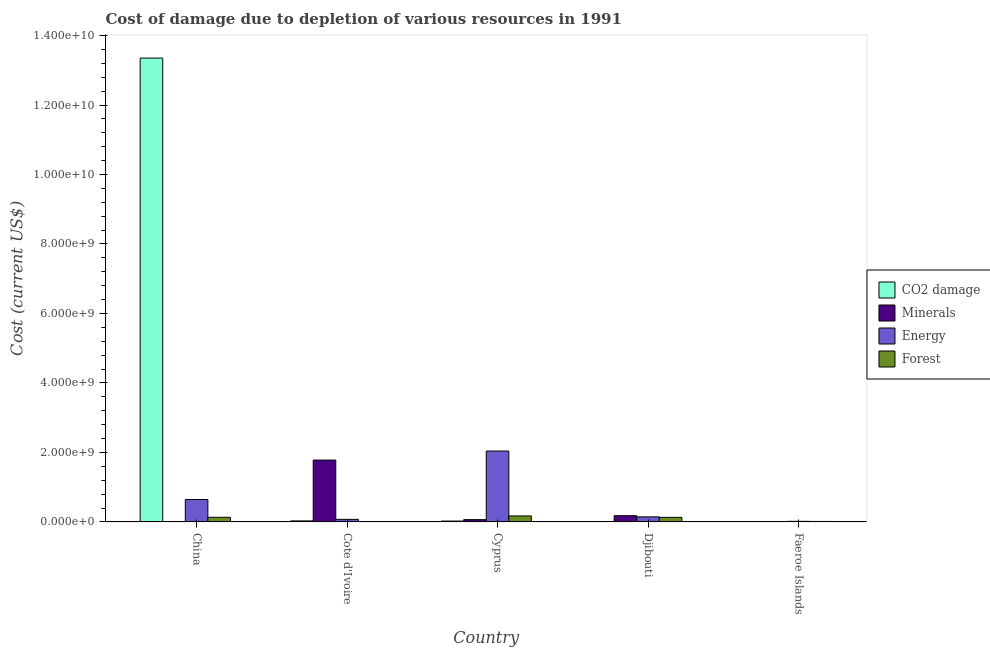How many groups of bars are there?
Keep it short and to the point. 5. How many bars are there on the 3rd tick from the left?
Your answer should be very brief. 4. How many bars are there on the 2nd tick from the right?
Keep it short and to the point. 4. What is the label of the 4th group of bars from the left?
Make the answer very short. Djibouti. What is the cost of damage due to depletion of coal in China?
Your response must be concise. 1.34e+1. Across all countries, what is the maximum cost of damage due to depletion of coal?
Provide a short and direct response. 1.34e+1. Across all countries, what is the minimum cost of damage due to depletion of energy?
Offer a very short reply. 1.68e+07. What is the total cost of damage due to depletion of forests in the graph?
Give a very brief answer. 4.50e+08. What is the difference between the cost of damage due to depletion of energy in China and that in Cote d'Ivoire?
Your answer should be very brief. 5.71e+08. What is the difference between the cost of damage due to depletion of coal in China and the cost of damage due to depletion of energy in Cote d'Ivoire?
Provide a succinct answer. 1.33e+1. What is the average cost of damage due to depletion of minerals per country?
Provide a succinct answer. 4.05e+08. What is the difference between the cost of damage due to depletion of coal and cost of damage due to depletion of energy in Cyprus?
Your answer should be compact. -2.02e+09. In how many countries, is the cost of damage due to depletion of forests greater than 9600000000 US$?
Provide a short and direct response. 0. What is the ratio of the cost of damage due to depletion of forests in Cyprus to that in Djibouti?
Offer a very short reply. 1.31. Is the difference between the cost of damage due to depletion of forests in Cote d'Ivoire and Djibouti greater than the difference between the cost of damage due to depletion of minerals in Cote d'Ivoire and Djibouti?
Make the answer very short. No. What is the difference between the highest and the second highest cost of damage due to depletion of minerals?
Your response must be concise. 1.60e+09. What is the difference between the highest and the lowest cost of damage due to depletion of coal?
Ensure brevity in your answer.  1.33e+1. Is it the case that in every country, the sum of the cost of damage due to depletion of minerals and cost of damage due to depletion of coal is greater than the sum of cost of damage due to depletion of energy and cost of damage due to depletion of forests?
Ensure brevity in your answer.  No. What does the 3rd bar from the left in China represents?
Give a very brief answer. Energy. What does the 3rd bar from the right in Cote d'Ivoire represents?
Your response must be concise. Minerals. Is it the case that in every country, the sum of the cost of damage due to depletion of coal and cost of damage due to depletion of minerals is greater than the cost of damage due to depletion of energy?
Provide a succinct answer. No. How many bars are there?
Offer a very short reply. 20. How many countries are there in the graph?
Provide a short and direct response. 5. Where does the legend appear in the graph?
Keep it short and to the point. Center right. How many legend labels are there?
Your answer should be very brief. 4. What is the title of the graph?
Give a very brief answer. Cost of damage due to depletion of various resources in 1991 . Does "UNRWA" appear as one of the legend labels in the graph?
Make the answer very short. No. What is the label or title of the X-axis?
Give a very brief answer. Country. What is the label or title of the Y-axis?
Offer a very short reply. Cost (current US$). What is the Cost (current US$) of CO2 damage in China?
Keep it short and to the point. 1.34e+1. What is the Cost (current US$) of Minerals in China?
Offer a terse response. 5762.35. What is the Cost (current US$) in Energy in China?
Provide a short and direct response. 6.45e+08. What is the Cost (current US$) of Forest in China?
Give a very brief answer. 1.33e+08. What is the Cost (current US$) in CO2 damage in Cote d'Ivoire?
Your response must be concise. 2.91e+07. What is the Cost (current US$) in Minerals in Cote d'Ivoire?
Keep it short and to the point. 1.78e+09. What is the Cost (current US$) in Energy in Cote d'Ivoire?
Make the answer very short. 7.38e+07. What is the Cost (current US$) of Forest in Cote d'Ivoire?
Offer a terse response. 2.44e+05. What is the Cost (current US$) of CO2 damage in Cyprus?
Make the answer very short. 2.45e+07. What is the Cost (current US$) of Minerals in Cyprus?
Offer a very short reply. 6.52e+07. What is the Cost (current US$) of Energy in Cyprus?
Keep it short and to the point. 2.04e+09. What is the Cost (current US$) of Forest in Cyprus?
Your answer should be compact. 1.72e+08. What is the Cost (current US$) in CO2 damage in Djibouti?
Provide a short and direct response. 1.97e+06. What is the Cost (current US$) of Minerals in Djibouti?
Give a very brief answer. 1.79e+08. What is the Cost (current US$) of Energy in Djibouti?
Provide a short and direct response. 1.45e+08. What is the Cost (current US$) in Forest in Djibouti?
Your response must be concise. 1.31e+08. What is the Cost (current US$) of CO2 damage in Faeroe Islands?
Your answer should be compact. 3.07e+06. What is the Cost (current US$) in Minerals in Faeroe Islands?
Offer a terse response. 1.46e+06. What is the Cost (current US$) of Energy in Faeroe Islands?
Keep it short and to the point. 1.68e+07. What is the Cost (current US$) of Forest in Faeroe Islands?
Offer a very short reply. 1.35e+07. Across all countries, what is the maximum Cost (current US$) in CO2 damage?
Make the answer very short. 1.34e+1. Across all countries, what is the maximum Cost (current US$) in Minerals?
Keep it short and to the point. 1.78e+09. Across all countries, what is the maximum Cost (current US$) in Energy?
Your answer should be compact. 2.04e+09. Across all countries, what is the maximum Cost (current US$) of Forest?
Ensure brevity in your answer.  1.72e+08. Across all countries, what is the minimum Cost (current US$) in CO2 damage?
Offer a very short reply. 1.97e+06. Across all countries, what is the minimum Cost (current US$) of Minerals?
Make the answer very short. 5762.35. Across all countries, what is the minimum Cost (current US$) of Energy?
Offer a terse response. 1.68e+07. Across all countries, what is the minimum Cost (current US$) in Forest?
Your answer should be compact. 2.44e+05. What is the total Cost (current US$) of CO2 damage in the graph?
Provide a succinct answer. 1.34e+1. What is the total Cost (current US$) in Minerals in the graph?
Offer a very short reply. 2.03e+09. What is the total Cost (current US$) of Energy in the graph?
Keep it short and to the point. 2.92e+09. What is the total Cost (current US$) in Forest in the graph?
Provide a succinct answer. 4.50e+08. What is the difference between the Cost (current US$) of CO2 damage in China and that in Cote d'Ivoire?
Give a very brief answer. 1.33e+1. What is the difference between the Cost (current US$) in Minerals in China and that in Cote d'Ivoire?
Make the answer very short. -1.78e+09. What is the difference between the Cost (current US$) of Energy in China and that in Cote d'Ivoire?
Ensure brevity in your answer.  5.71e+08. What is the difference between the Cost (current US$) in Forest in China and that in Cote d'Ivoire?
Keep it short and to the point. 1.33e+08. What is the difference between the Cost (current US$) of CO2 damage in China and that in Cyprus?
Provide a succinct answer. 1.33e+1. What is the difference between the Cost (current US$) in Minerals in China and that in Cyprus?
Offer a very short reply. -6.52e+07. What is the difference between the Cost (current US$) in Energy in China and that in Cyprus?
Ensure brevity in your answer.  -1.39e+09. What is the difference between the Cost (current US$) in Forest in China and that in Cyprus?
Keep it short and to the point. -3.91e+07. What is the difference between the Cost (current US$) in CO2 damage in China and that in Djibouti?
Ensure brevity in your answer.  1.33e+1. What is the difference between the Cost (current US$) of Minerals in China and that in Djibouti?
Offer a very short reply. -1.79e+08. What is the difference between the Cost (current US$) in Energy in China and that in Djibouti?
Make the answer very short. 5.00e+08. What is the difference between the Cost (current US$) of Forest in China and that in Djibouti?
Give a very brief answer. 2.08e+06. What is the difference between the Cost (current US$) of CO2 damage in China and that in Faeroe Islands?
Your response must be concise. 1.33e+1. What is the difference between the Cost (current US$) in Minerals in China and that in Faeroe Islands?
Offer a very short reply. -1.45e+06. What is the difference between the Cost (current US$) of Energy in China and that in Faeroe Islands?
Your answer should be compact. 6.28e+08. What is the difference between the Cost (current US$) in Forest in China and that in Faeroe Islands?
Your answer should be very brief. 1.20e+08. What is the difference between the Cost (current US$) of CO2 damage in Cote d'Ivoire and that in Cyprus?
Your answer should be compact. 4.62e+06. What is the difference between the Cost (current US$) in Minerals in Cote d'Ivoire and that in Cyprus?
Provide a succinct answer. 1.71e+09. What is the difference between the Cost (current US$) of Energy in Cote d'Ivoire and that in Cyprus?
Your answer should be very brief. -1.97e+09. What is the difference between the Cost (current US$) in Forest in Cote d'Ivoire and that in Cyprus?
Make the answer very short. -1.72e+08. What is the difference between the Cost (current US$) of CO2 damage in Cote d'Ivoire and that in Djibouti?
Offer a terse response. 2.71e+07. What is the difference between the Cost (current US$) in Minerals in Cote d'Ivoire and that in Djibouti?
Your response must be concise. 1.60e+09. What is the difference between the Cost (current US$) in Energy in Cote d'Ivoire and that in Djibouti?
Your answer should be very brief. -7.14e+07. What is the difference between the Cost (current US$) of Forest in Cote d'Ivoire and that in Djibouti?
Ensure brevity in your answer.  -1.31e+08. What is the difference between the Cost (current US$) in CO2 damage in Cote d'Ivoire and that in Faeroe Islands?
Offer a very short reply. 2.60e+07. What is the difference between the Cost (current US$) in Minerals in Cote d'Ivoire and that in Faeroe Islands?
Your response must be concise. 1.78e+09. What is the difference between the Cost (current US$) in Energy in Cote d'Ivoire and that in Faeroe Islands?
Offer a very short reply. 5.71e+07. What is the difference between the Cost (current US$) of Forest in Cote d'Ivoire and that in Faeroe Islands?
Offer a very short reply. -1.33e+07. What is the difference between the Cost (current US$) in CO2 damage in Cyprus and that in Djibouti?
Your answer should be compact. 2.25e+07. What is the difference between the Cost (current US$) of Minerals in Cyprus and that in Djibouti?
Keep it short and to the point. -1.13e+08. What is the difference between the Cost (current US$) of Energy in Cyprus and that in Djibouti?
Your answer should be very brief. 1.89e+09. What is the difference between the Cost (current US$) in Forest in Cyprus and that in Djibouti?
Offer a terse response. 4.12e+07. What is the difference between the Cost (current US$) in CO2 damage in Cyprus and that in Faeroe Islands?
Give a very brief answer. 2.14e+07. What is the difference between the Cost (current US$) of Minerals in Cyprus and that in Faeroe Islands?
Offer a very short reply. 6.37e+07. What is the difference between the Cost (current US$) of Energy in Cyprus and that in Faeroe Islands?
Provide a succinct answer. 2.02e+09. What is the difference between the Cost (current US$) in Forest in Cyprus and that in Faeroe Islands?
Ensure brevity in your answer.  1.59e+08. What is the difference between the Cost (current US$) of CO2 damage in Djibouti and that in Faeroe Islands?
Your answer should be compact. -1.10e+06. What is the difference between the Cost (current US$) of Minerals in Djibouti and that in Faeroe Islands?
Offer a very short reply. 1.77e+08. What is the difference between the Cost (current US$) of Energy in Djibouti and that in Faeroe Islands?
Your response must be concise. 1.29e+08. What is the difference between the Cost (current US$) of Forest in Djibouti and that in Faeroe Islands?
Your answer should be very brief. 1.18e+08. What is the difference between the Cost (current US$) of CO2 damage in China and the Cost (current US$) of Minerals in Cote d'Ivoire?
Make the answer very short. 1.16e+1. What is the difference between the Cost (current US$) in CO2 damage in China and the Cost (current US$) in Energy in Cote d'Ivoire?
Provide a short and direct response. 1.33e+1. What is the difference between the Cost (current US$) in CO2 damage in China and the Cost (current US$) in Forest in Cote d'Ivoire?
Your response must be concise. 1.34e+1. What is the difference between the Cost (current US$) in Minerals in China and the Cost (current US$) in Energy in Cote d'Ivoire?
Provide a succinct answer. -7.38e+07. What is the difference between the Cost (current US$) of Minerals in China and the Cost (current US$) of Forest in Cote d'Ivoire?
Keep it short and to the point. -2.39e+05. What is the difference between the Cost (current US$) in Energy in China and the Cost (current US$) in Forest in Cote d'Ivoire?
Offer a terse response. 6.45e+08. What is the difference between the Cost (current US$) of CO2 damage in China and the Cost (current US$) of Minerals in Cyprus?
Ensure brevity in your answer.  1.33e+1. What is the difference between the Cost (current US$) of CO2 damage in China and the Cost (current US$) of Energy in Cyprus?
Provide a succinct answer. 1.13e+1. What is the difference between the Cost (current US$) of CO2 damage in China and the Cost (current US$) of Forest in Cyprus?
Your response must be concise. 1.32e+1. What is the difference between the Cost (current US$) in Minerals in China and the Cost (current US$) in Energy in Cyprus?
Ensure brevity in your answer.  -2.04e+09. What is the difference between the Cost (current US$) in Minerals in China and the Cost (current US$) in Forest in Cyprus?
Keep it short and to the point. -1.72e+08. What is the difference between the Cost (current US$) of Energy in China and the Cost (current US$) of Forest in Cyprus?
Provide a succinct answer. 4.73e+08. What is the difference between the Cost (current US$) of CO2 damage in China and the Cost (current US$) of Minerals in Djibouti?
Your answer should be compact. 1.32e+1. What is the difference between the Cost (current US$) of CO2 damage in China and the Cost (current US$) of Energy in Djibouti?
Make the answer very short. 1.32e+1. What is the difference between the Cost (current US$) of CO2 damage in China and the Cost (current US$) of Forest in Djibouti?
Ensure brevity in your answer.  1.32e+1. What is the difference between the Cost (current US$) in Minerals in China and the Cost (current US$) in Energy in Djibouti?
Offer a terse response. -1.45e+08. What is the difference between the Cost (current US$) in Minerals in China and the Cost (current US$) in Forest in Djibouti?
Provide a short and direct response. -1.31e+08. What is the difference between the Cost (current US$) in Energy in China and the Cost (current US$) in Forest in Djibouti?
Keep it short and to the point. 5.14e+08. What is the difference between the Cost (current US$) of CO2 damage in China and the Cost (current US$) of Minerals in Faeroe Islands?
Keep it short and to the point. 1.33e+1. What is the difference between the Cost (current US$) in CO2 damage in China and the Cost (current US$) in Energy in Faeroe Islands?
Offer a very short reply. 1.33e+1. What is the difference between the Cost (current US$) in CO2 damage in China and the Cost (current US$) in Forest in Faeroe Islands?
Provide a short and direct response. 1.33e+1. What is the difference between the Cost (current US$) of Minerals in China and the Cost (current US$) of Energy in Faeroe Islands?
Your answer should be very brief. -1.68e+07. What is the difference between the Cost (current US$) in Minerals in China and the Cost (current US$) in Forest in Faeroe Islands?
Your response must be concise. -1.35e+07. What is the difference between the Cost (current US$) of Energy in China and the Cost (current US$) of Forest in Faeroe Islands?
Make the answer very short. 6.31e+08. What is the difference between the Cost (current US$) of CO2 damage in Cote d'Ivoire and the Cost (current US$) of Minerals in Cyprus?
Make the answer very short. -3.61e+07. What is the difference between the Cost (current US$) in CO2 damage in Cote d'Ivoire and the Cost (current US$) in Energy in Cyprus?
Offer a terse response. -2.01e+09. What is the difference between the Cost (current US$) of CO2 damage in Cote d'Ivoire and the Cost (current US$) of Forest in Cyprus?
Offer a terse response. -1.43e+08. What is the difference between the Cost (current US$) in Minerals in Cote d'Ivoire and the Cost (current US$) in Energy in Cyprus?
Make the answer very short. -2.60e+08. What is the difference between the Cost (current US$) in Minerals in Cote d'Ivoire and the Cost (current US$) in Forest in Cyprus?
Provide a short and direct response. 1.61e+09. What is the difference between the Cost (current US$) of Energy in Cote d'Ivoire and the Cost (current US$) of Forest in Cyprus?
Make the answer very short. -9.84e+07. What is the difference between the Cost (current US$) of CO2 damage in Cote d'Ivoire and the Cost (current US$) of Minerals in Djibouti?
Give a very brief answer. -1.49e+08. What is the difference between the Cost (current US$) of CO2 damage in Cote d'Ivoire and the Cost (current US$) of Energy in Djibouti?
Your response must be concise. -1.16e+08. What is the difference between the Cost (current US$) of CO2 damage in Cote d'Ivoire and the Cost (current US$) of Forest in Djibouti?
Make the answer very short. -1.02e+08. What is the difference between the Cost (current US$) in Minerals in Cote d'Ivoire and the Cost (current US$) in Energy in Djibouti?
Provide a short and direct response. 1.63e+09. What is the difference between the Cost (current US$) of Minerals in Cote d'Ivoire and the Cost (current US$) of Forest in Djibouti?
Offer a terse response. 1.65e+09. What is the difference between the Cost (current US$) of Energy in Cote d'Ivoire and the Cost (current US$) of Forest in Djibouti?
Your answer should be compact. -5.72e+07. What is the difference between the Cost (current US$) in CO2 damage in Cote d'Ivoire and the Cost (current US$) in Minerals in Faeroe Islands?
Give a very brief answer. 2.77e+07. What is the difference between the Cost (current US$) of CO2 damage in Cote d'Ivoire and the Cost (current US$) of Energy in Faeroe Islands?
Ensure brevity in your answer.  1.24e+07. What is the difference between the Cost (current US$) in CO2 damage in Cote d'Ivoire and the Cost (current US$) in Forest in Faeroe Islands?
Provide a short and direct response. 1.56e+07. What is the difference between the Cost (current US$) in Minerals in Cote d'Ivoire and the Cost (current US$) in Energy in Faeroe Islands?
Your response must be concise. 1.76e+09. What is the difference between the Cost (current US$) in Minerals in Cote d'Ivoire and the Cost (current US$) in Forest in Faeroe Islands?
Provide a succinct answer. 1.77e+09. What is the difference between the Cost (current US$) in Energy in Cote d'Ivoire and the Cost (current US$) in Forest in Faeroe Islands?
Provide a short and direct response. 6.03e+07. What is the difference between the Cost (current US$) in CO2 damage in Cyprus and the Cost (current US$) in Minerals in Djibouti?
Keep it short and to the point. -1.54e+08. What is the difference between the Cost (current US$) of CO2 damage in Cyprus and the Cost (current US$) of Energy in Djibouti?
Offer a very short reply. -1.21e+08. What is the difference between the Cost (current US$) of CO2 damage in Cyprus and the Cost (current US$) of Forest in Djibouti?
Provide a short and direct response. -1.07e+08. What is the difference between the Cost (current US$) in Minerals in Cyprus and the Cost (current US$) in Energy in Djibouti?
Your answer should be very brief. -8.01e+07. What is the difference between the Cost (current US$) in Minerals in Cyprus and the Cost (current US$) in Forest in Djibouti?
Give a very brief answer. -6.59e+07. What is the difference between the Cost (current US$) of Energy in Cyprus and the Cost (current US$) of Forest in Djibouti?
Offer a terse response. 1.91e+09. What is the difference between the Cost (current US$) in CO2 damage in Cyprus and the Cost (current US$) in Minerals in Faeroe Islands?
Your answer should be compact. 2.30e+07. What is the difference between the Cost (current US$) of CO2 damage in Cyprus and the Cost (current US$) of Energy in Faeroe Islands?
Ensure brevity in your answer.  7.74e+06. What is the difference between the Cost (current US$) of CO2 damage in Cyprus and the Cost (current US$) of Forest in Faeroe Islands?
Offer a terse response. 1.10e+07. What is the difference between the Cost (current US$) of Minerals in Cyprus and the Cost (current US$) of Energy in Faeroe Islands?
Your answer should be compact. 4.84e+07. What is the difference between the Cost (current US$) in Minerals in Cyprus and the Cost (current US$) in Forest in Faeroe Islands?
Your answer should be very brief. 5.17e+07. What is the difference between the Cost (current US$) in Energy in Cyprus and the Cost (current US$) in Forest in Faeroe Islands?
Your response must be concise. 2.03e+09. What is the difference between the Cost (current US$) in CO2 damage in Djibouti and the Cost (current US$) in Minerals in Faeroe Islands?
Your answer should be very brief. 5.14e+05. What is the difference between the Cost (current US$) of CO2 damage in Djibouti and the Cost (current US$) of Energy in Faeroe Islands?
Give a very brief answer. -1.48e+07. What is the difference between the Cost (current US$) in CO2 damage in Djibouti and the Cost (current US$) in Forest in Faeroe Islands?
Make the answer very short. -1.16e+07. What is the difference between the Cost (current US$) in Minerals in Djibouti and the Cost (current US$) in Energy in Faeroe Islands?
Make the answer very short. 1.62e+08. What is the difference between the Cost (current US$) of Minerals in Djibouti and the Cost (current US$) of Forest in Faeroe Islands?
Give a very brief answer. 1.65e+08. What is the difference between the Cost (current US$) of Energy in Djibouti and the Cost (current US$) of Forest in Faeroe Islands?
Provide a short and direct response. 1.32e+08. What is the average Cost (current US$) in CO2 damage per country?
Make the answer very short. 2.68e+09. What is the average Cost (current US$) in Minerals per country?
Your answer should be very brief. 4.05e+08. What is the average Cost (current US$) in Energy per country?
Your answer should be very brief. 5.84e+08. What is the average Cost (current US$) in Forest per country?
Ensure brevity in your answer.  9.00e+07. What is the difference between the Cost (current US$) of CO2 damage and Cost (current US$) of Minerals in China?
Make the answer very short. 1.34e+1. What is the difference between the Cost (current US$) of CO2 damage and Cost (current US$) of Energy in China?
Your answer should be very brief. 1.27e+1. What is the difference between the Cost (current US$) in CO2 damage and Cost (current US$) in Forest in China?
Your response must be concise. 1.32e+1. What is the difference between the Cost (current US$) of Minerals and Cost (current US$) of Energy in China?
Your response must be concise. -6.45e+08. What is the difference between the Cost (current US$) in Minerals and Cost (current US$) in Forest in China?
Your answer should be very brief. -1.33e+08. What is the difference between the Cost (current US$) in Energy and Cost (current US$) in Forest in China?
Your response must be concise. 5.12e+08. What is the difference between the Cost (current US$) of CO2 damage and Cost (current US$) of Minerals in Cote d'Ivoire?
Your answer should be very brief. -1.75e+09. What is the difference between the Cost (current US$) in CO2 damage and Cost (current US$) in Energy in Cote d'Ivoire?
Your answer should be compact. -4.47e+07. What is the difference between the Cost (current US$) in CO2 damage and Cost (current US$) in Forest in Cote d'Ivoire?
Offer a terse response. 2.89e+07. What is the difference between the Cost (current US$) in Minerals and Cost (current US$) in Energy in Cote d'Ivoire?
Your answer should be very brief. 1.71e+09. What is the difference between the Cost (current US$) of Minerals and Cost (current US$) of Forest in Cote d'Ivoire?
Ensure brevity in your answer.  1.78e+09. What is the difference between the Cost (current US$) in Energy and Cost (current US$) in Forest in Cote d'Ivoire?
Ensure brevity in your answer.  7.36e+07. What is the difference between the Cost (current US$) of CO2 damage and Cost (current US$) of Minerals in Cyprus?
Offer a terse response. -4.07e+07. What is the difference between the Cost (current US$) of CO2 damage and Cost (current US$) of Energy in Cyprus?
Provide a succinct answer. -2.02e+09. What is the difference between the Cost (current US$) of CO2 damage and Cost (current US$) of Forest in Cyprus?
Your answer should be compact. -1.48e+08. What is the difference between the Cost (current US$) of Minerals and Cost (current US$) of Energy in Cyprus?
Give a very brief answer. -1.97e+09. What is the difference between the Cost (current US$) of Minerals and Cost (current US$) of Forest in Cyprus?
Keep it short and to the point. -1.07e+08. What is the difference between the Cost (current US$) of Energy and Cost (current US$) of Forest in Cyprus?
Your response must be concise. 1.87e+09. What is the difference between the Cost (current US$) of CO2 damage and Cost (current US$) of Minerals in Djibouti?
Your answer should be compact. -1.77e+08. What is the difference between the Cost (current US$) in CO2 damage and Cost (current US$) in Energy in Djibouti?
Offer a very short reply. -1.43e+08. What is the difference between the Cost (current US$) in CO2 damage and Cost (current US$) in Forest in Djibouti?
Offer a terse response. -1.29e+08. What is the difference between the Cost (current US$) in Minerals and Cost (current US$) in Energy in Djibouti?
Ensure brevity in your answer.  3.33e+07. What is the difference between the Cost (current US$) in Minerals and Cost (current US$) in Forest in Djibouti?
Offer a very short reply. 4.76e+07. What is the difference between the Cost (current US$) in Energy and Cost (current US$) in Forest in Djibouti?
Ensure brevity in your answer.  1.42e+07. What is the difference between the Cost (current US$) of CO2 damage and Cost (current US$) of Minerals in Faeroe Islands?
Give a very brief answer. 1.61e+06. What is the difference between the Cost (current US$) of CO2 damage and Cost (current US$) of Energy in Faeroe Islands?
Ensure brevity in your answer.  -1.37e+07. What is the difference between the Cost (current US$) in CO2 damage and Cost (current US$) in Forest in Faeroe Islands?
Make the answer very short. -1.05e+07. What is the difference between the Cost (current US$) of Minerals and Cost (current US$) of Energy in Faeroe Islands?
Your response must be concise. -1.53e+07. What is the difference between the Cost (current US$) in Minerals and Cost (current US$) in Forest in Faeroe Islands?
Ensure brevity in your answer.  -1.21e+07. What is the difference between the Cost (current US$) in Energy and Cost (current US$) in Forest in Faeroe Islands?
Ensure brevity in your answer.  3.23e+06. What is the ratio of the Cost (current US$) in CO2 damage in China to that in Cote d'Ivoire?
Your answer should be very brief. 458.56. What is the ratio of the Cost (current US$) in Energy in China to that in Cote d'Ivoire?
Your answer should be very brief. 8.73. What is the ratio of the Cost (current US$) in Forest in China to that in Cote d'Ivoire?
Provide a short and direct response. 545.01. What is the ratio of the Cost (current US$) of CO2 damage in China to that in Cyprus?
Provide a succinct answer. 545.1. What is the ratio of the Cost (current US$) of Minerals in China to that in Cyprus?
Give a very brief answer. 0. What is the ratio of the Cost (current US$) in Energy in China to that in Cyprus?
Your answer should be compact. 0.32. What is the ratio of the Cost (current US$) in Forest in China to that in Cyprus?
Provide a succinct answer. 0.77. What is the ratio of the Cost (current US$) in CO2 damage in China to that in Djibouti?
Make the answer very short. 6777.02. What is the ratio of the Cost (current US$) of Minerals in China to that in Djibouti?
Your answer should be compact. 0. What is the ratio of the Cost (current US$) in Energy in China to that in Djibouti?
Ensure brevity in your answer.  4.44. What is the ratio of the Cost (current US$) of Forest in China to that in Djibouti?
Give a very brief answer. 1.02. What is the ratio of the Cost (current US$) of CO2 damage in China to that in Faeroe Islands?
Keep it short and to the point. 4350.68. What is the ratio of the Cost (current US$) in Minerals in China to that in Faeroe Islands?
Offer a terse response. 0. What is the ratio of the Cost (current US$) in Energy in China to that in Faeroe Islands?
Your response must be concise. 38.48. What is the ratio of the Cost (current US$) in Forest in China to that in Faeroe Islands?
Give a very brief answer. 9.84. What is the ratio of the Cost (current US$) of CO2 damage in Cote d'Ivoire to that in Cyprus?
Offer a terse response. 1.19. What is the ratio of the Cost (current US$) in Minerals in Cote d'Ivoire to that in Cyprus?
Provide a succinct answer. 27.3. What is the ratio of the Cost (current US$) in Energy in Cote d'Ivoire to that in Cyprus?
Give a very brief answer. 0.04. What is the ratio of the Cost (current US$) in Forest in Cote d'Ivoire to that in Cyprus?
Your response must be concise. 0. What is the ratio of the Cost (current US$) of CO2 damage in Cote d'Ivoire to that in Djibouti?
Your answer should be very brief. 14.78. What is the ratio of the Cost (current US$) in Minerals in Cote d'Ivoire to that in Djibouti?
Your answer should be compact. 9.96. What is the ratio of the Cost (current US$) in Energy in Cote d'Ivoire to that in Djibouti?
Offer a very short reply. 0.51. What is the ratio of the Cost (current US$) in Forest in Cote d'Ivoire to that in Djibouti?
Your answer should be very brief. 0. What is the ratio of the Cost (current US$) in CO2 damage in Cote d'Ivoire to that in Faeroe Islands?
Provide a short and direct response. 9.49. What is the ratio of the Cost (current US$) in Minerals in Cote d'Ivoire to that in Faeroe Islands?
Offer a very short reply. 1221.96. What is the ratio of the Cost (current US$) in Energy in Cote d'Ivoire to that in Faeroe Islands?
Make the answer very short. 4.41. What is the ratio of the Cost (current US$) of Forest in Cote d'Ivoire to that in Faeroe Islands?
Your answer should be very brief. 0.02. What is the ratio of the Cost (current US$) of CO2 damage in Cyprus to that in Djibouti?
Give a very brief answer. 12.43. What is the ratio of the Cost (current US$) of Minerals in Cyprus to that in Djibouti?
Keep it short and to the point. 0.36. What is the ratio of the Cost (current US$) of Energy in Cyprus to that in Djibouti?
Your response must be concise. 14.04. What is the ratio of the Cost (current US$) in Forest in Cyprus to that in Djibouti?
Offer a terse response. 1.31. What is the ratio of the Cost (current US$) of CO2 damage in Cyprus to that in Faeroe Islands?
Your answer should be very brief. 7.98. What is the ratio of the Cost (current US$) of Minerals in Cyprus to that in Faeroe Islands?
Offer a very short reply. 44.77. What is the ratio of the Cost (current US$) in Energy in Cyprus to that in Faeroe Islands?
Your response must be concise. 121.71. What is the ratio of the Cost (current US$) in Forest in Cyprus to that in Faeroe Islands?
Your answer should be compact. 12.73. What is the ratio of the Cost (current US$) of CO2 damage in Djibouti to that in Faeroe Islands?
Provide a short and direct response. 0.64. What is the ratio of the Cost (current US$) of Minerals in Djibouti to that in Faeroe Islands?
Ensure brevity in your answer.  122.63. What is the ratio of the Cost (current US$) of Energy in Djibouti to that in Faeroe Islands?
Offer a terse response. 8.67. What is the ratio of the Cost (current US$) in Forest in Djibouti to that in Faeroe Islands?
Your answer should be very brief. 9.69. What is the difference between the highest and the second highest Cost (current US$) in CO2 damage?
Your answer should be very brief. 1.33e+1. What is the difference between the highest and the second highest Cost (current US$) of Minerals?
Provide a short and direct response. 1.60e+09. What is the difference between the highest and the second highest Cost (current US$) in Energy?
Ensure brevity in your answer.  1.39e+09. What is the difference between the highest and the second highest Cost (current US$) of Forest?
Ensure brevity in your answer.  3.91e+07. What is the difference between the highest and the lowest Cost (current US$) in CO2 damage?
Ensure brevity in your answer.  1.33e+1. What is the difference between the highest and the lowest Cost (current US$) in Minerals?
Your answer should be compact. 1.78e+09. What is the difference between the highest and the lowest Cost (current US$) in Energy?
Offer a very short reply. 2.02e+09. What is the difference between the highest and the lowest Cost (current US$) of Forest?
Provide a succinct answer. 1.72e+08. 